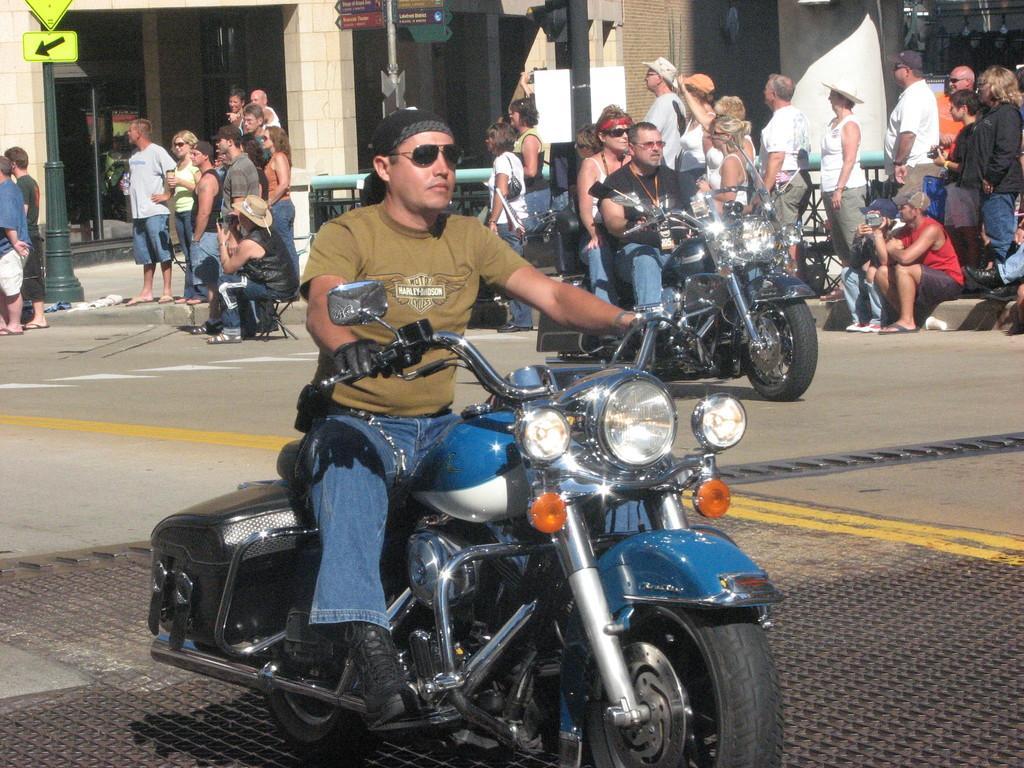Could you give a brief overview of what you see in this image? A man is riding bike on the road. Behind him there are few people standing and a sign pole,building and two people on bike riding. 